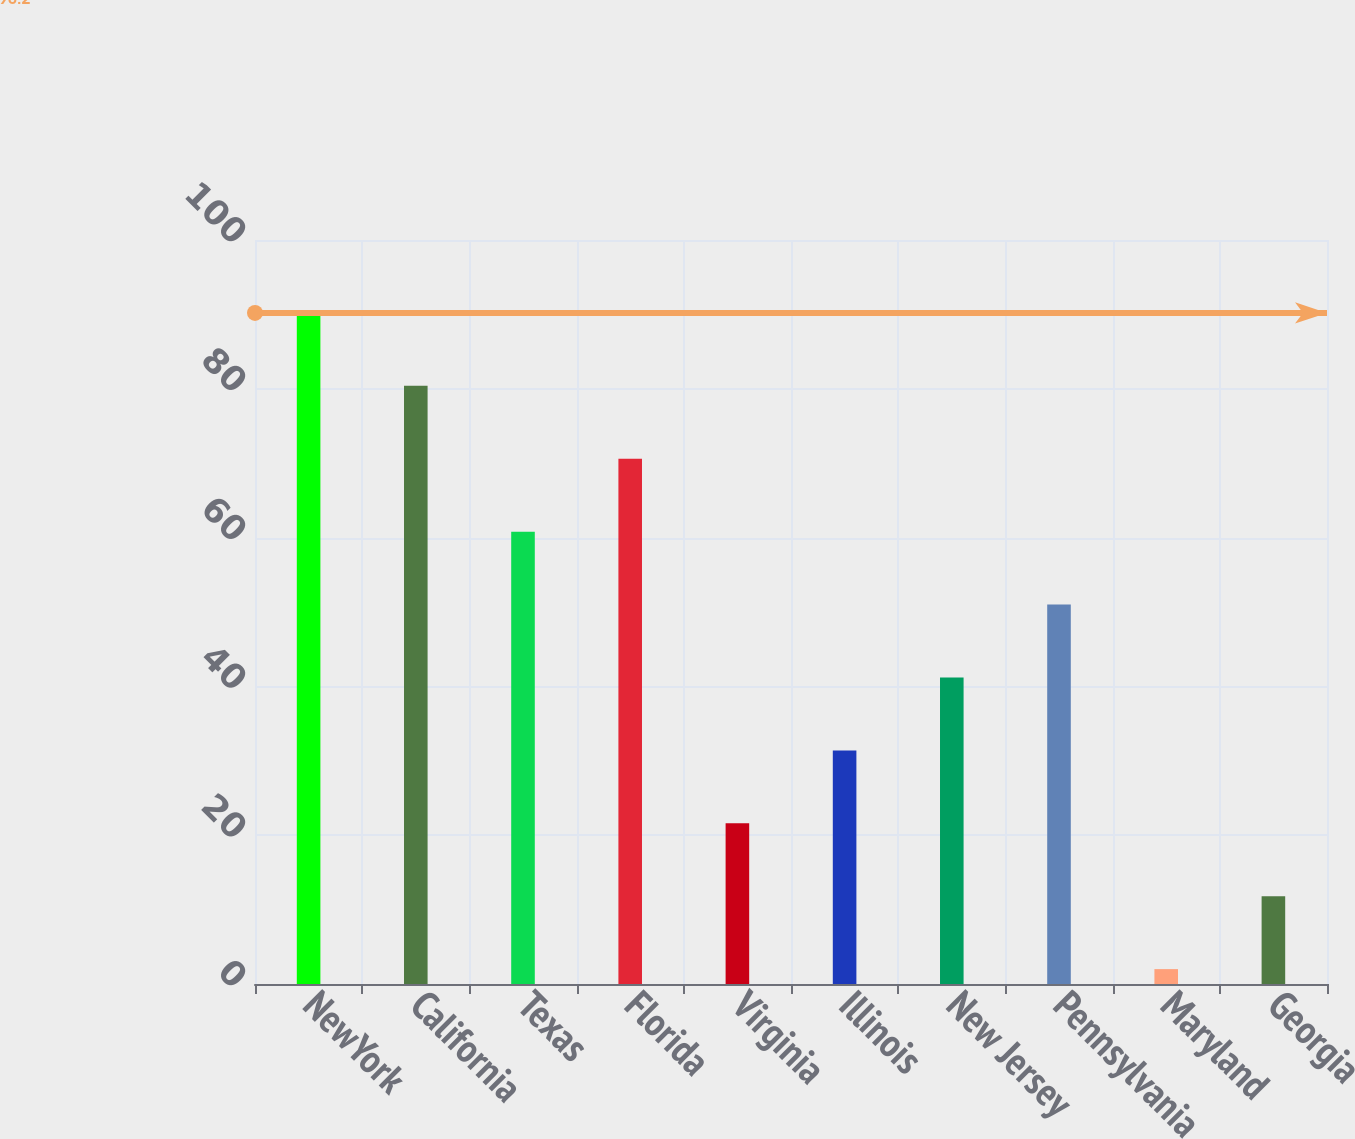<chart> <loc_0><loc_0><loc_500><loc_500><bar_chart><fcel>NewYork<fcel>California<fcel>Texas<fcel>Florida<fcel>Virginia<fcel>Illinois<fcel>New Jersey<fcel>Pennsylvania<fcel>Maryland<fcel>Georgia<nl><fcel>90.2<fcel>80.4<fcel>60.8<fcel>70.6<fcel>21.6<fcel>31.4<fcel>41.2<fcel>51<fcel>2<fcel>11.8<nl></chart> 